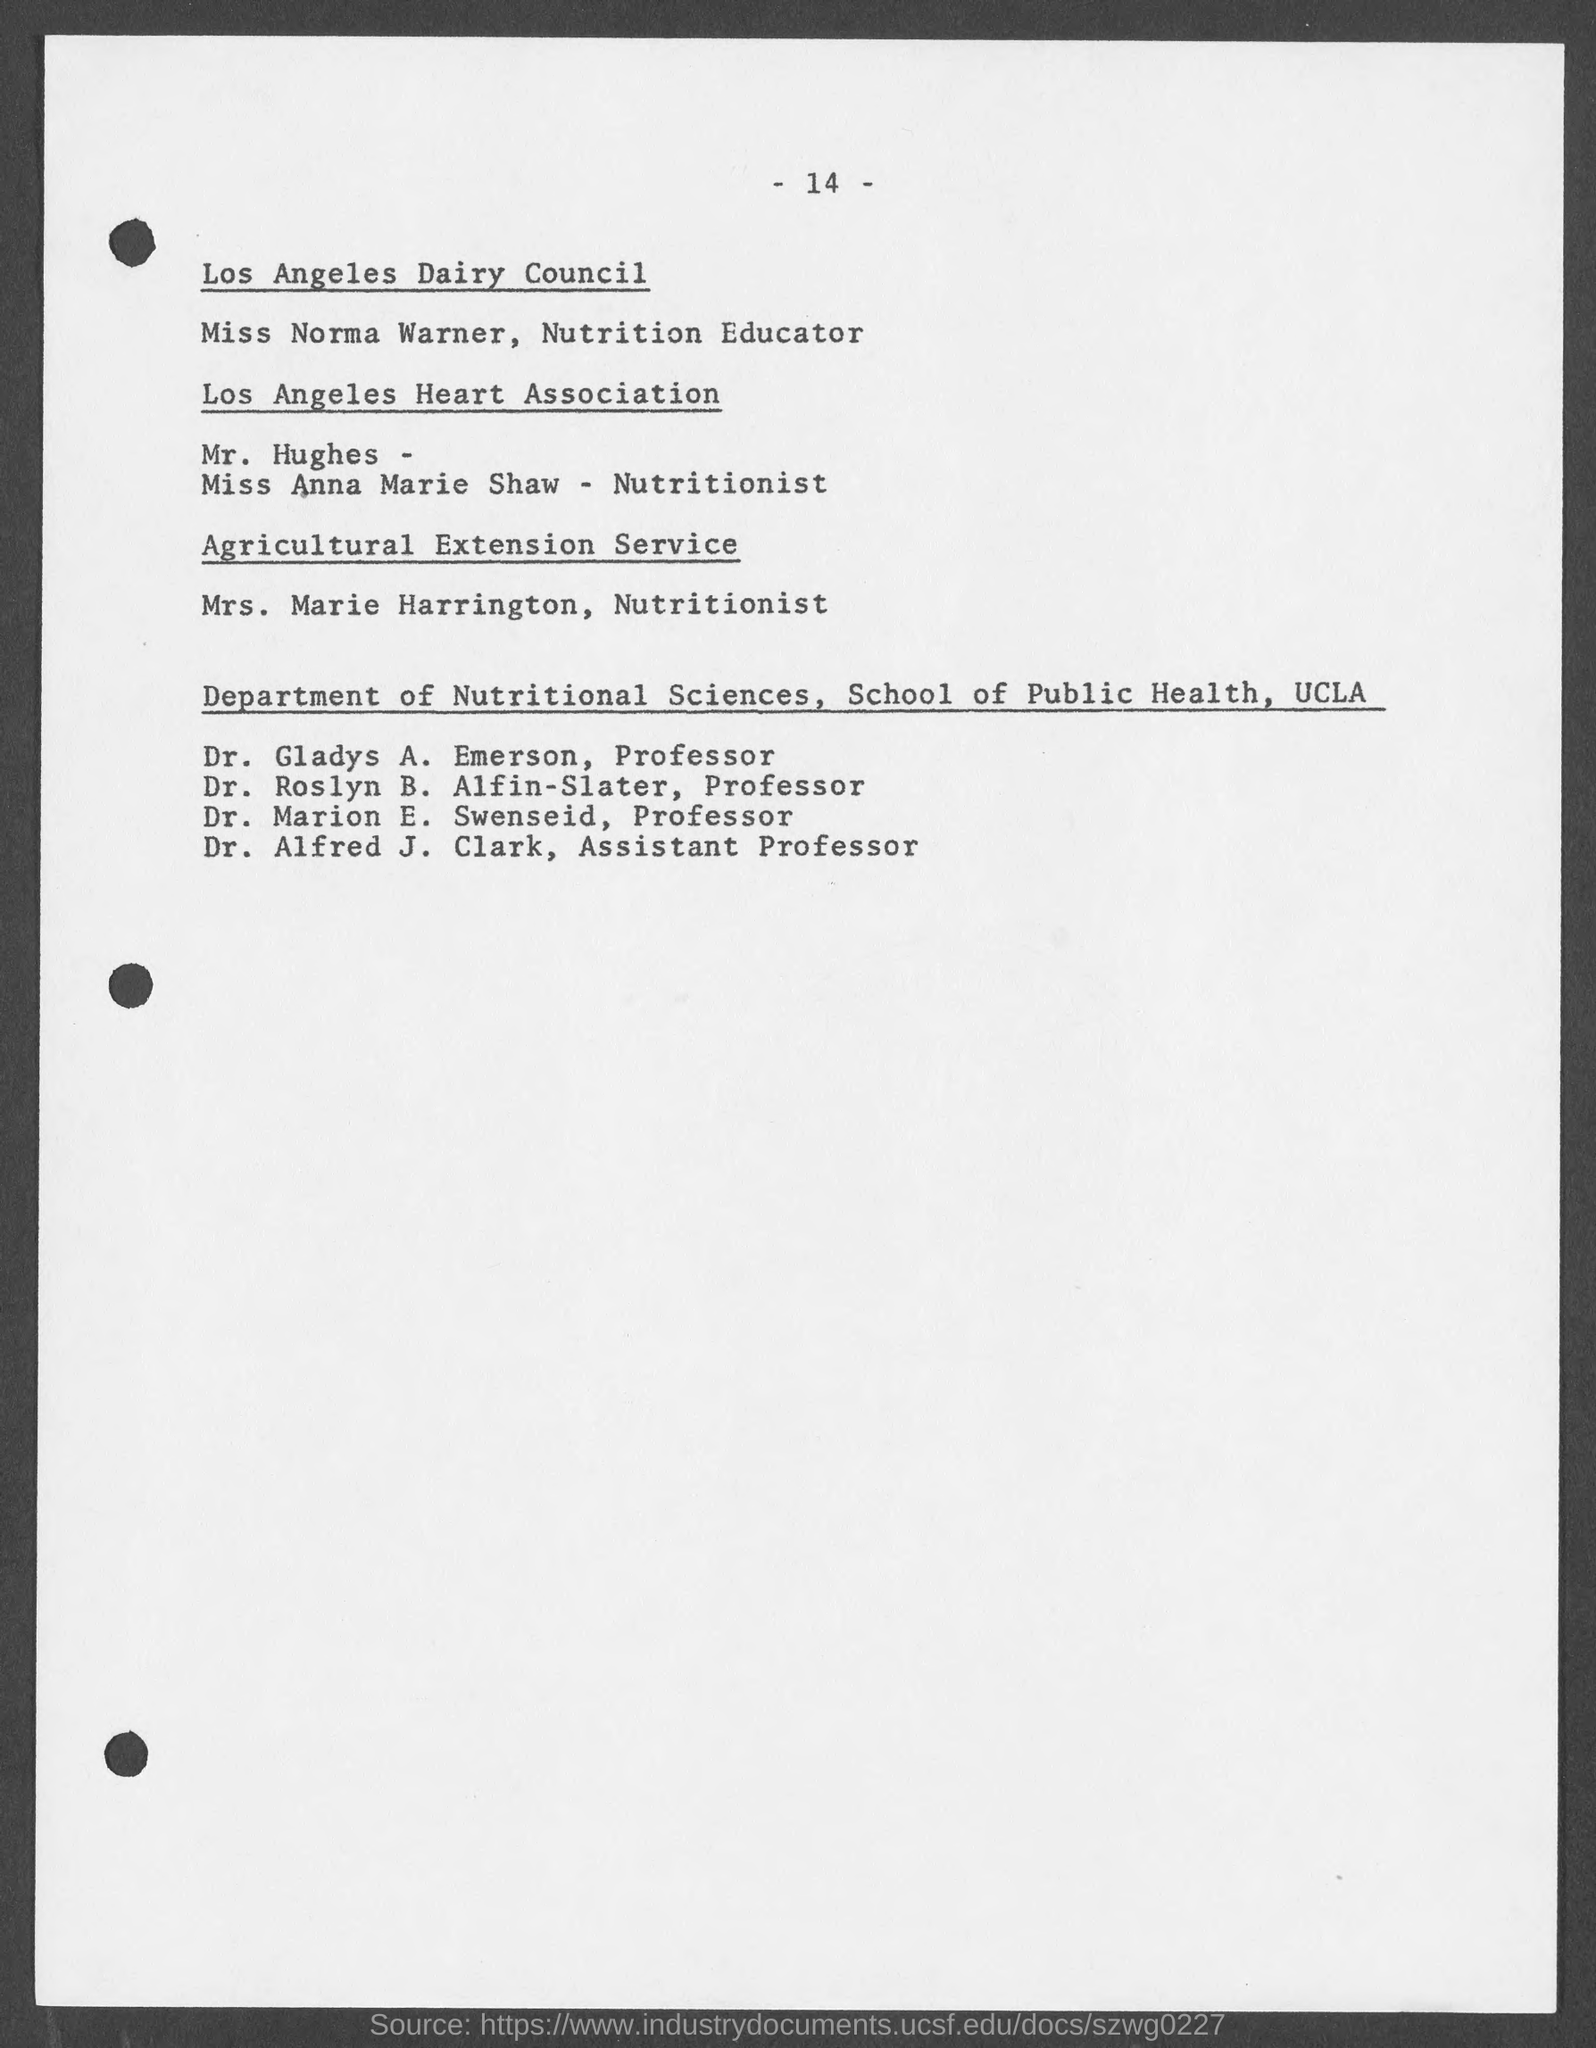What is the page no mentioned in this document?
Offer a terse response. - 14 -. Who is the Nutritionist in Agricultural Extension Service?
Your response must be concise. Mrs. Marie Harrington. Who is the Assistant Professor in Department of Nutritional Sciences, School of Public Health, UCLA?
Provide a succinct answer. Dr. Alfred J. Clark. 